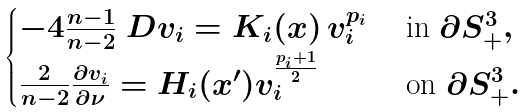<formula> <loc_0><loc_0><loc_500><loc_500>\begin{cases} - 4 \frac { n - 1 } { n - 2 } \ D v _ { i } = K _ { i } ( x ) \, v _ { i } ^ { p _ { i } } & \text { in } \partial S ^ { 3 } _ { + } , \\ \frac { 2 } { n - 2 } \frac { \partial v _ { i } } { \partial \nu } = H _ { i } ( x ^ { \prime } ) v _ { i } ^ { \frac { p _ { i } + 1 } { 2 } } & \text { on } \partial S ^ { 3 } _ { + } . \end{cases}</formula> 